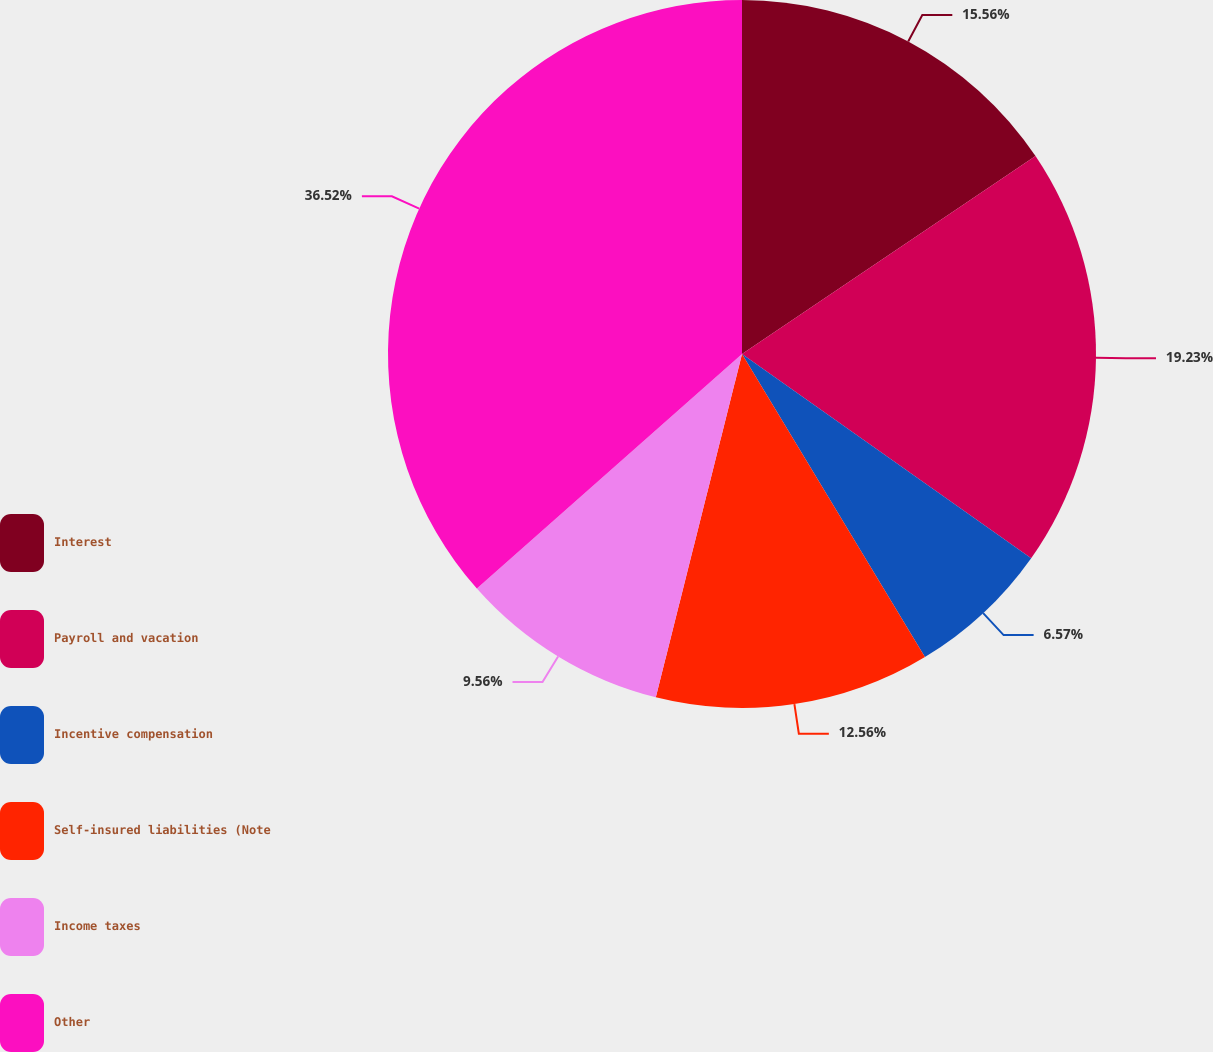<chart> <loc_0><loc_0><loc_500><loc_500><pie_chart><fcel>Interest<fcel>Payroll and vacation<fcel>Incentive compensation<fcel>Self-insured liabilities (Note<fcel>Income taxes<fcel>Other<nl><fcel>15.56%<fcel>19.23%<fcel>6.57%<fcel>12.56%<fcel>9.56%<fcel>36.53%<nl></chart> 